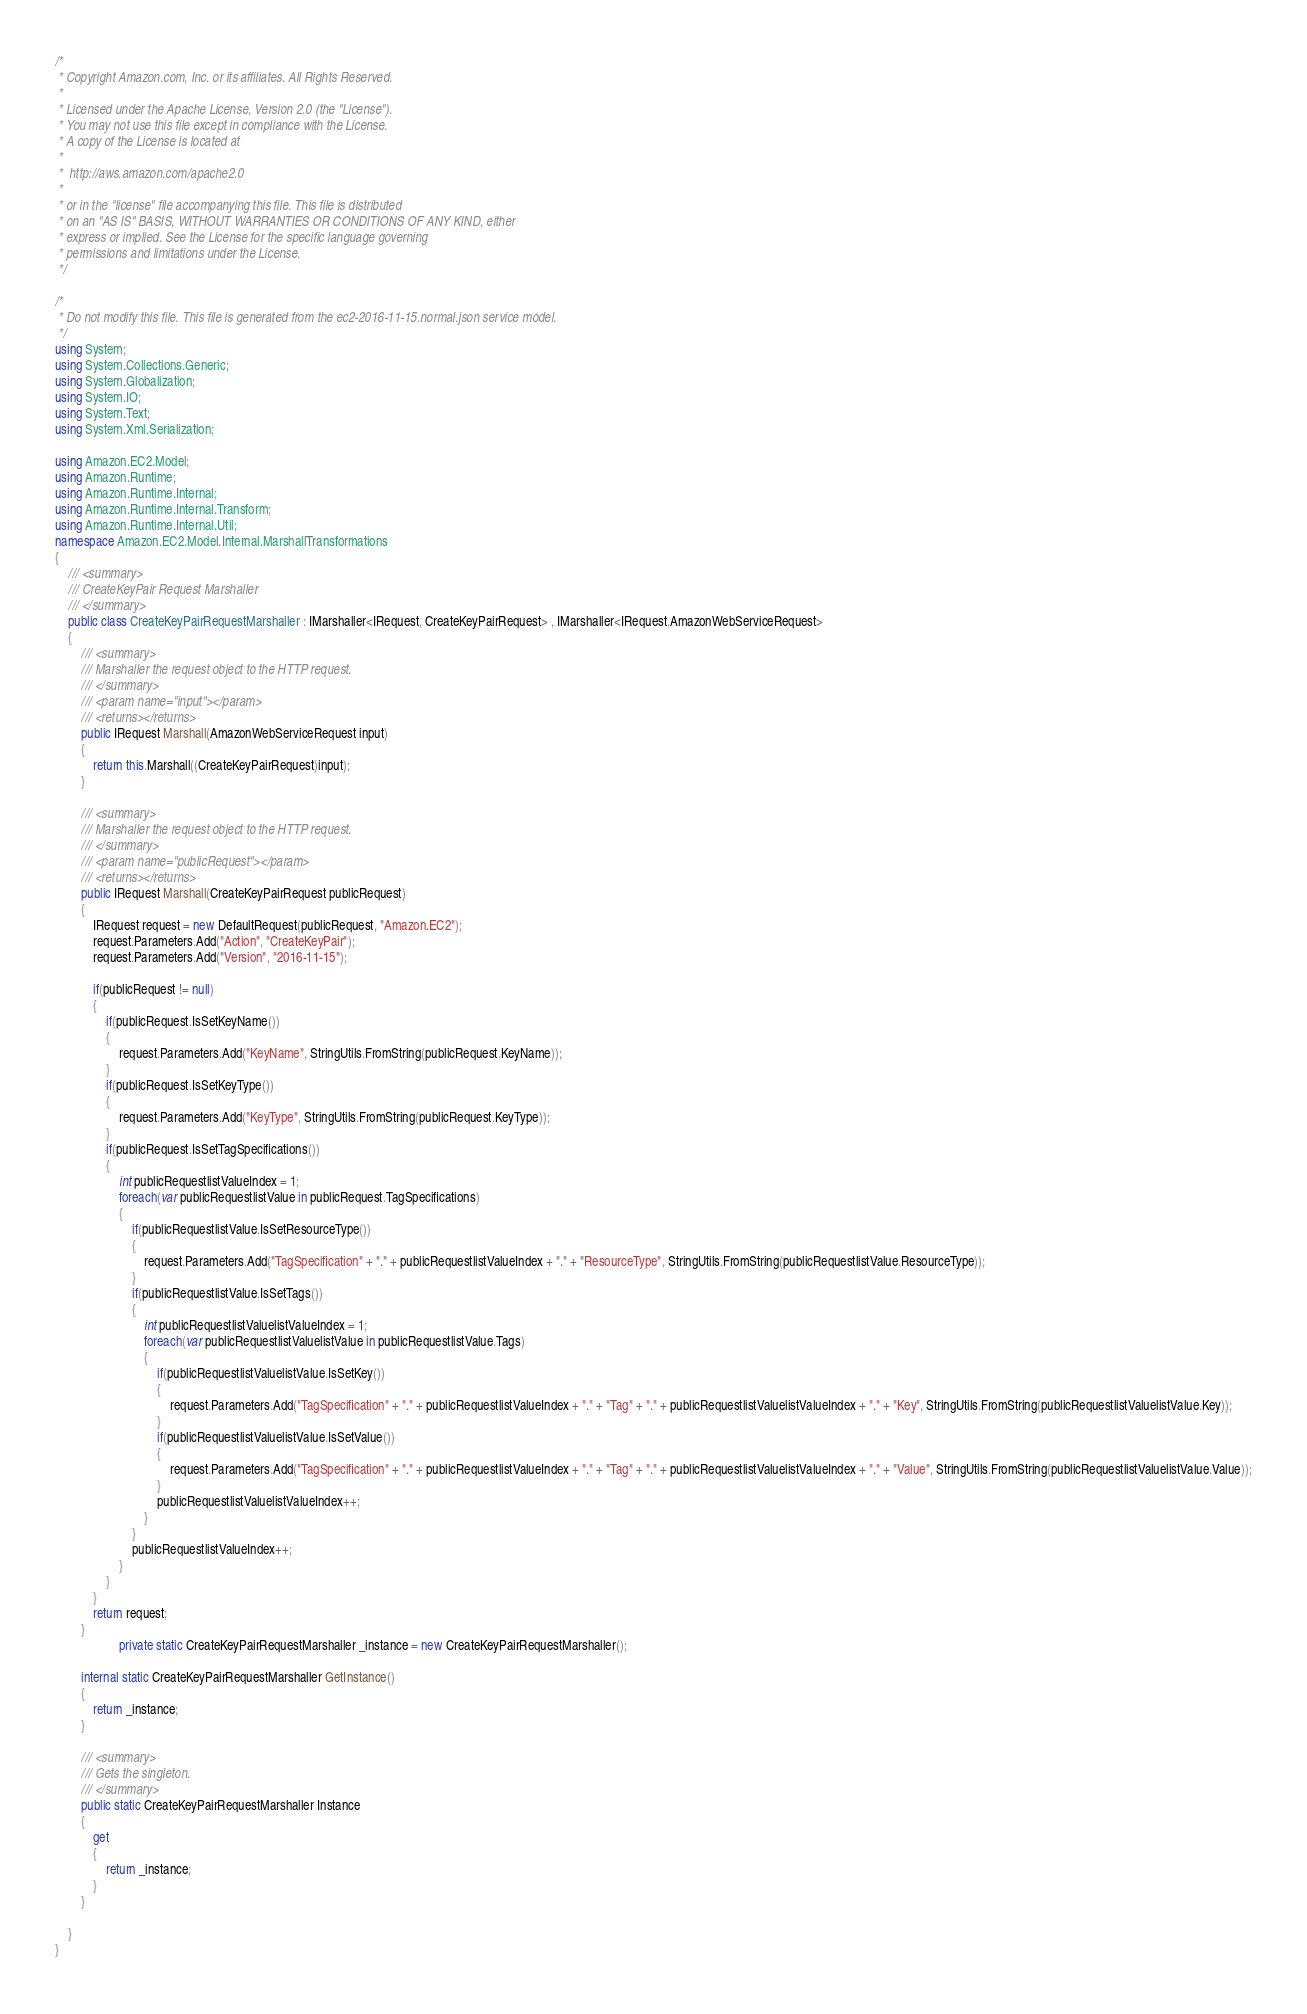<code> <loc_0><loc_0><loc_500><loc_500><_C#_>/*
 * Copyright Amazon.com, Inc. or its affiliates. All Rights Reserved.
 * 
 * Licensed under the Apache License, Version 2.0 (the "License").
 * You may not use this file except in compliance with the License.
 * A copy of the License is located at
 * 
 *  http://aws.amazon.com/apache2.0
 * 
 * or in the "license" file accompanying this file. This file is distributed
 * on an "AS IS" BASIS, WITHOUT WARRANTIES OR CONDITIONS OF ANY KIND, either
 * express or implied. See the License for the specific language governing
 * permissions and limitations under the License.
 */

/*
 * Do not modify this file. This file is generated from the ec2-2016-11-15.normal.json service model.
 */
using System;
using System.Collections.Generic;
using System.Globalization;
using System.IO;
using System.Text;
using System.Xml.Serialization;

using Amazon.EC2.Model;
using Amazon.Runtime;
using Amazon.Runtime.Internal;
using Amazon.Runtime.Internal.Transform;
using Amazon.Runtime.Internal.Util;
namespace Amazon.EC2.Model.Internal.MarshallTransformations
{
    /// <summary>
    /// CreateKeyPair Request Marshaller
    /// </summary>       
    public class CreateKeyPairRequestMarshaller : IMarshaller<IRequest, CreateKeyPairRequest> , IMarshaller<IRequest,AmazonWebServiceRequest>
    {
        /// <summary>
        /// Marshaller the request object to the HTTP request.
        /// </summary>  
        /// <param name="input"></param>
        /// <returns></returns>
        public IRequest Marshall(AmazonWebServiceRequest input)
        {
            return this.Marshall((CreateKeyPairRequest)input);
        }
    
        /// <summary>
        /// Marshaller the request object to the HTTP request.
        /// </summary>  
        /// <param name="publicRequest"></param>
        /// <returns></returns>
        public IRequest Marshall(CreateKeyPairRequest publicRequest)
        {
            IRequest request = new DefaultRequest(publicRequest, "Amazon.EC2");
            request.Parameters.Add("Action", "CreateKeyPair");
            request.Parameters.Add("Version", "2016-11-15");

            if(publicRequest != null)
            {
                if(publicRequest.IsSetKeyName())
                {
                    request.Parameters.Add("KeyName", StringUtils.FromString(publicRequest.KeyName));
                }
                if(publicRequest.IsSetKeyType())
                {
                    request.Parameters.Add("KeyType", StringUtils.FromString(publicRequest.KeyType));
                }
                if(publicRequest.IsSetTagSpecifications())
                {
                    int publicRequestlistValueIndex = 1;
                    foreach(var publicRequestlistValue in publicRequest.TagSpecifications)
                    {
                        if(publicRequestlistValue.IsSetResourceType())
                        {
                            request.Parameters.Add("TagSpecification" + "." + publicRequestlistValueIndex + "." + "ResourceType", StringUtils.FromString(publicRequestlistValue.ResourceType));
                        }
                        if(publicRequestlistValue.IsSetTags())
                        {
                            int publicRequestlistValuelistValueIndex = 1;
                            foreach(var publicRequestlistValuelistValue in publicRequestlistValue.Tags)
                            {
                                if(publicRequestlistValuelistValue.IsSetKey())
                                {
                                    request.Parameters.Add("TagSpecification" + "." + publicRequestlistValueIndex + "." + "Tag" + "." + publicRequestlistValuelistValueIndex + "." + "Key", StringUtils.FromString(publicRequestlistValuelistValue.Key));
                                }
                                if(publicRequestlistValuelistValue.IsSetValue())
                                {
                                    request.Parameters.Add("TagSpecification" + "." + publicRequestlistValueIndex + "." + "Tag" + "." + publicRequestlistValuelistValueIndex + "." + "Value", StringUtils.FromString(publicRequestlistValuelistValue.Value));
                                }
                                publicRequestlistValuelistValueIndex++;
                            }
                        }
                        publicRequestlistValueIndex++;
                    }
                }
            }
            return request;
        }
                    private static CreateKeyPairRequestMarshaller _instance = new CreateKeyPairRequestMarshaller();        

        internal static CreateKeyPairRequestMarshaller GetInstance()
        {
            return _instance;
        }

        /// <summary>
        /// Gets the singleton.
        /// </summary>  
        public static CreateKeyPairRequestMarshaller Instance
        {
            get
            {
                return _instance;
            }
        }

    }
}</code> 